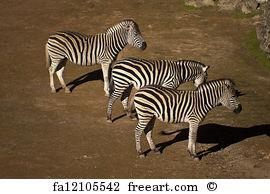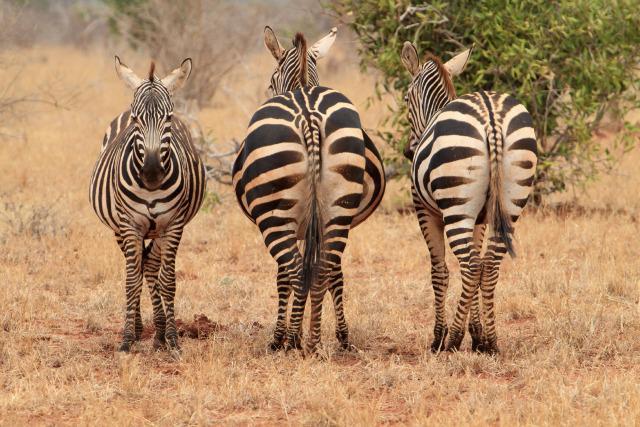The first image is the image on the left, the second image is the image on the right. For the images displayed, is the sentence "there are 6 zebras in the image pair" factually correct? Answer yes or no. Yes. The first image is the image on the left, the second image is the image on the right. Analyze the images presented: Is the assertion "Each image contains exactly three foreground zebra that are close together in similar poses." valid? Answer yes or no. Yes. 